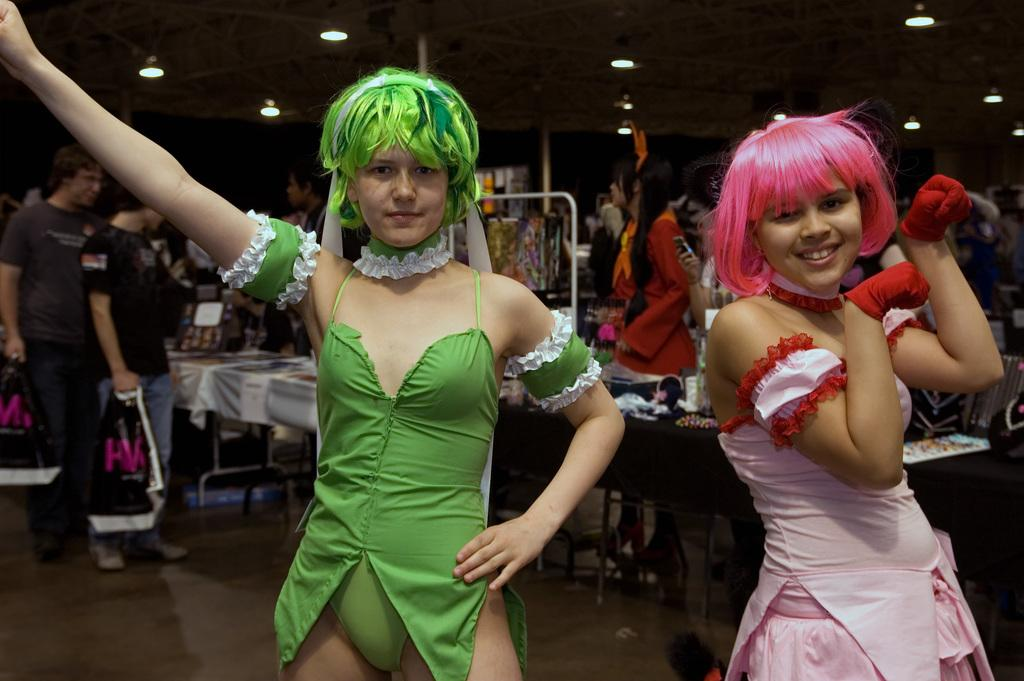How many girls are in the image? There are two girls in the image. What colors are the dresses of the girls? One girl is wearing a green dress, and the other girl is wearing a pink dress. Can you describe the people in the background of the image? There are people visible in the background of the image, but no specific details are provided. What is on the table in the image? There is a table with things on it in the image, but no specific details are provided. What is the texture of the tooth in the image? There is no tooth present in the image. What country is depicted in the image? The image does not depict a specific country; it features two girls and a background with people and a table. 